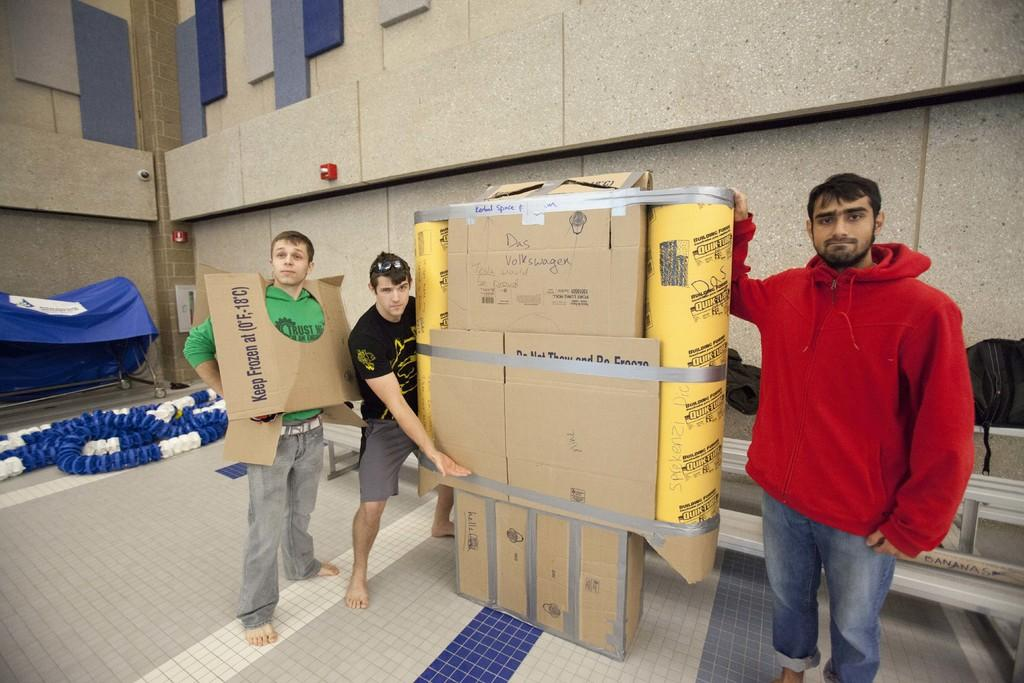<image>
Write a terse but informative summary of the picture. A man is wearing a cardboard box around his neck that says "keep frozen" on it. 